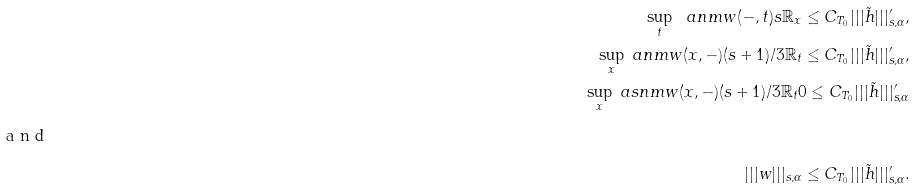Convert formula to latex. <formula><loc_0><loc_0><loc_500><loc_500>\sup _ { t } \ a n m { w ( - , t ) } { s } { { \mathbb { R } } _ { x } } \leq C _ { T _ { 0 } } | | | \tilde { h } | | | ^ { \prime } _ { s , \alpha } , \\ \sup _ { x } \ a n m { w ( x , - ) } { ( s + 1 ) / 3 } { { \mathbb { R } } _ { t } } \leq C _ { T _ { 0 } } | | | \tilde { h } | | | ^ { \prime } _ { s , \alpha } , \\ \sup _ { x } \ a s n m { w ( x , - ) } { ( s + 1 ) / 3 } { { \mathbb { R } } _ { t } } { 0 } \leq C _ { T _ { 0 } } | | | \tilde { h } | | | ^ { \prime } _ { s , \alpha } \\ \intertext { a n d } | | | w | | | _ { s , \alpha } \leq C _ { T _ { 0 } } | | | \tilde { h } | | | ^ { \prime } _ { s , \alpha } .</formula> 